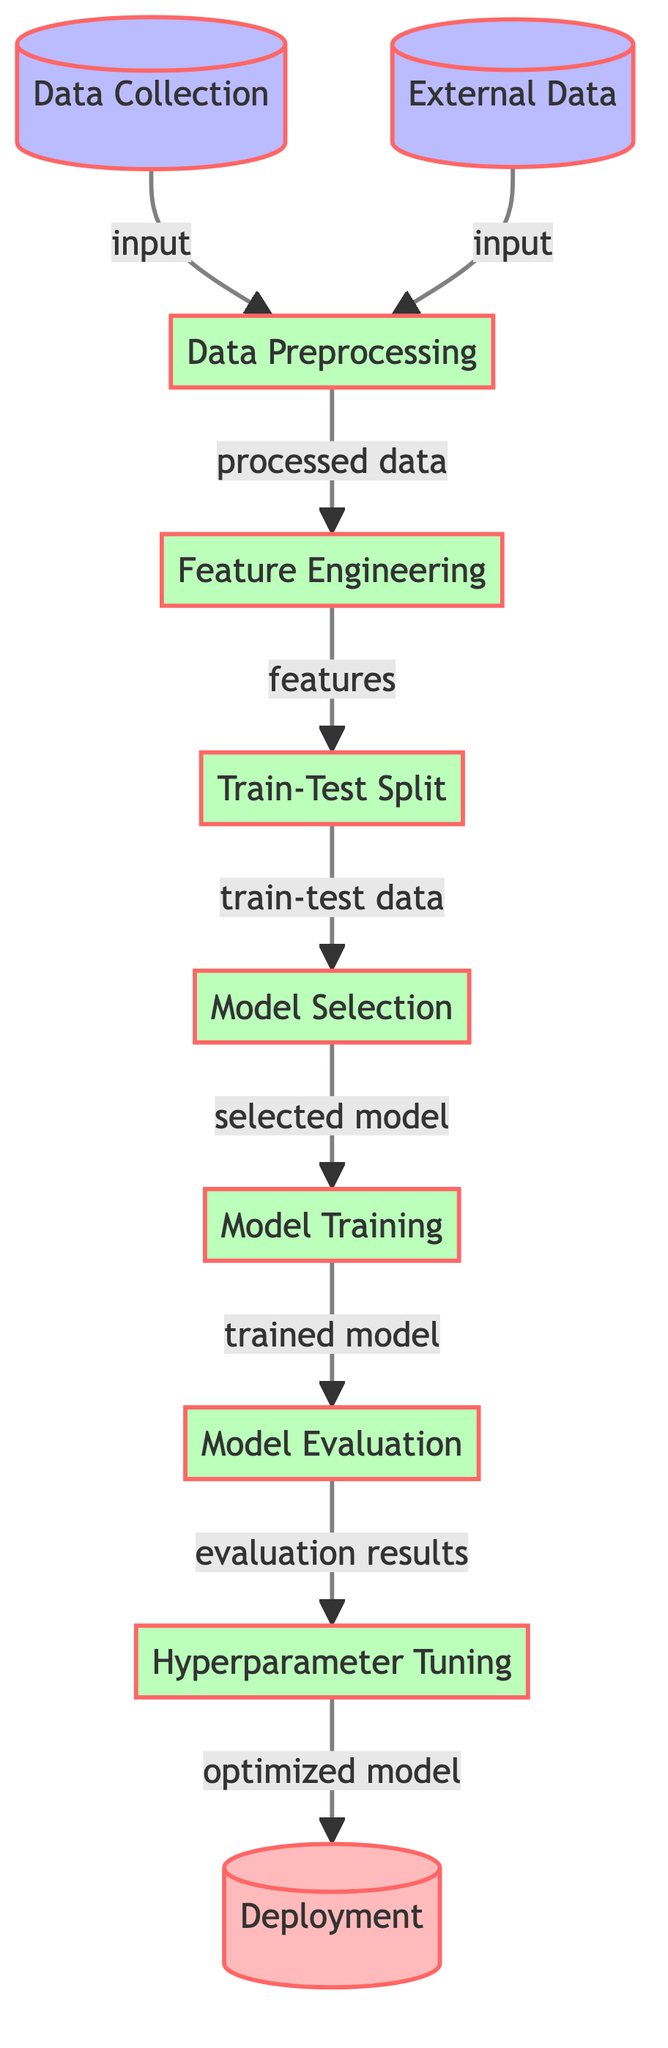What is the first step in the diagram? The first step is "Data Collection," which is represented as the first node on the left side. It is labeled clearly, indicating that it's the initial process in the flow.
Answer: Data Collection How many processes are there in the diagram? The diagram includes five processes: Data Preprocessing, Feature Engineering, Train-Test Split, Model Selection, Model Training, Model Evaluation, and Hyperparameter Tuning. By counting the nodes labeled with the "process" style, we find a total of seven processes.
Answer: Seven What type of data is input into the diagram? The types of input data shown in the diagram are "Data Collection" and "External Data," which are represented as distinct nodes at the beginning of the flow, indicating the starting point for the information used in the model.
Answer: Data Collection, External Data Which step comes after the "Model Training"? The step that follows "Model Training" in the flow is "Model Evaluation." By following the arrows from the "Model Training" node, you can see the direct connection leading to the next step.
Answer: Model Evaluation What is the final output of the diagram? The final output of the diagram is "Deployment," which is the last node in the flow designated for output. This indicates the end goal after all previous processing and evaluation steps have been completed.
Answer: Deployment Which node receives processed data from the feature engineering stage? The node that receives processed data from "Feature Engineering" is "Train-Test Split." This relationship can be traced by following the arrow indicating the flow of data from "Feature Engineering" to "Train-Test Split."
Answer: Train-Test Split How many input types are there in the diagram? There are two types of input in the diagram: "Data Collection" and "External Data." Each input type is represented as a separate node connected to the processing stage, indicating they are distinct sources of information.
Answer: Two What step is immediately before "Hyperparameter Tuning"? The step that comes immediately before "Hyperparameter Tuning" is "Model Evaluation." By examining the flow of the diagram, it is clear that the arrow points from "Model Evaluation" to "Hyperparameter Tuning," indicating the sequence.
Answer: Model Evaluation 